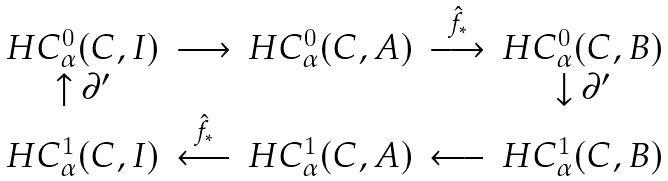Convert formula to latex. <formula><loc_0><loc_0><loc_500><loc_500>\begin{matrix} H C _ { \alpha } ^ { 0 } ( C , I ) & \longrightarrow & H C _ { \alpha } ^ { 0 } ( C , A ) & \overset { \hat { f } _ { * } } { \longrightarrow } & H C _ { \alpha } ^ { 0 } ( C , B ) \\ \uparrow \partial ^ { \prime } & & & & \downarrow \partial ^ { \prime } \\ H C _ { \alpha } ^ { 1 } ( C , I ) & \overset { \hat { f } _ { * } } { \longleftarrow } & H C _ { \alpha } ^ { 1 } ( C , A ) & \longleftarrow & H C _ { \alpha } ^ { 1 } ( C , B ) \end{matrix} \</formula> 